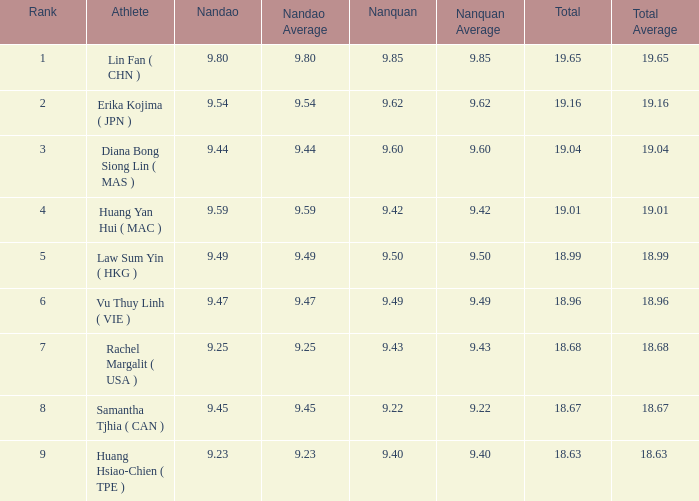Which Nanquan has a Nandao larger than 9.49, and a Rank of 4? 9.42. Help me parse the entirety of this table. {'header': ['Rank', 'Athlete', 'Nandao', 'Nandao Average', 'Nanquan', 'Nanquan Average', 'Total', 'Total Average'], 'rows': [['1', 'Lin Fan ( CHN )', '9.80', '9.80', '9.85', '9.85', '19.65', '19.65'], ['2', 'Erika Kojima ( JPN )', '9.54', '9.54', '9.62', '9.62', '19.16', '19.16'], ['3', 'Diana Bong Siong Lin ( MAS )', '9.44', '9.44', '9.60', '9.60', '19.04', '19.04'], ['4', 'Huang Yan Hui ( MAC )', '9.59', '9.59', '9.42', '9.42', '19.01', '19.01'], ['5', 'Law Sum Yin ( HKG )', '9.49', '9.49', '9.50', '9.50', '18.99', '18.99'], ['6', 'Vu Thuy Linh ( VIE )', '9.47', '9.47', '9.49', '9.49', '18.96', '18.96'], ['7', 'Rachel Margalit ( USA )', '9.25', '9.25', '9.43', '9.43', '18.68', '18.68'], ['8', 'Samantha Tjhia ( CAN )', '9.45', '9.45', '9.22', '9.22', '18.67', '18.67'], ['9', 'Huang Hsiao-Chien ( TPE )', '9.23', '9.23', '9.40', '9.40', '18.63', '18.63 ']]} 